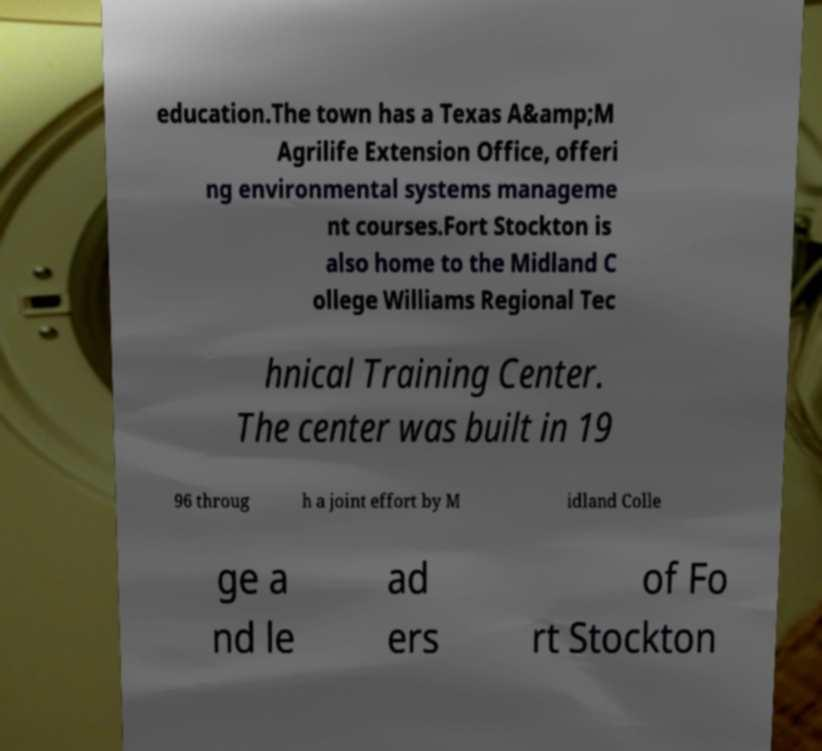Could you extract and type out the text from this image? education.The town has a Texas A&amp;M Agrilife Extension Office, offeri ng environmental systems manageme nt courses.Fort Stockton is also home to the Midland C ollege Williams Regional Tec hnical Training Center. The center was built in 19 96 throug h a joint effort by M idland Colle ge a nd le ad ers of Fo rt Stockton 